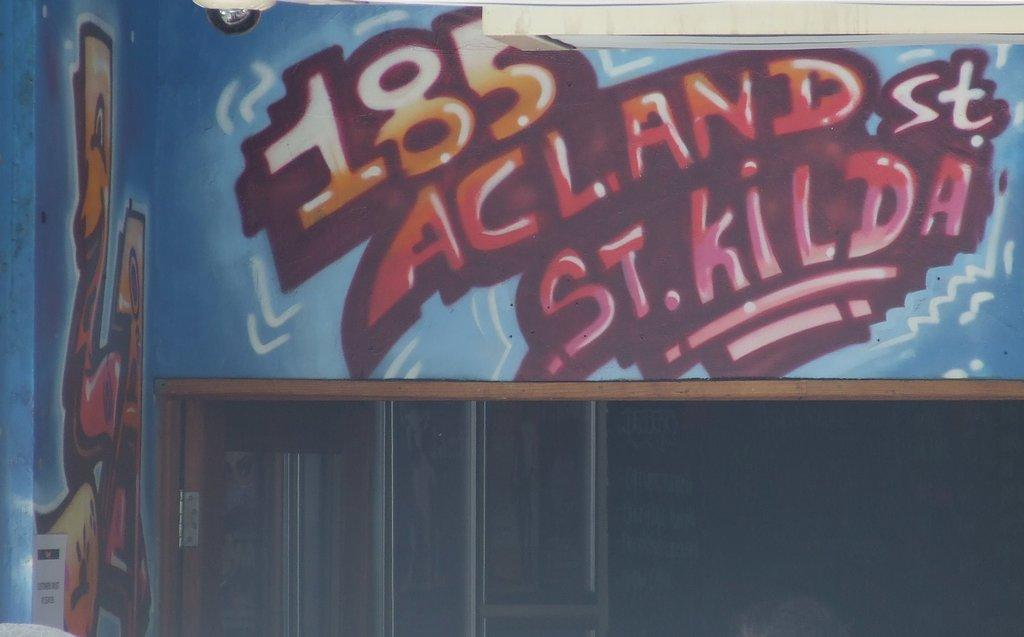Provide a one-sentence caption for the provided image. Graffiti image with a address on a back wall or a billboard it includes orange and blue,. 